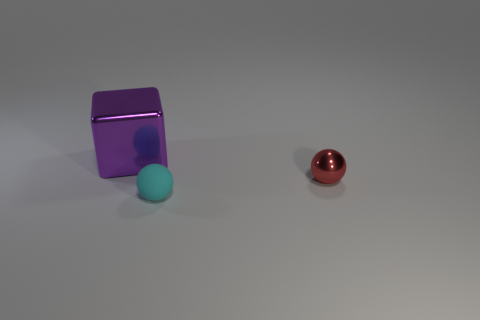Is the shape of the metallic thing that is to the left of the red metallic thing the same as the tiny thing that is right of the tiny rubber thing?
Give a very brief answer. No. Is there a tiny cyan ball?
Your response must be concise. Yes. There is a tiny red object that is the same shape as the cyan thing; what is it made of?
Offer a very short reply. Metal. There is a tiny cyan rubber ball; are there any small cyan objects behind it?
Provide a succinct answer. No. Does the small ball behind the tiny matte object have the same material as the big purple cube?
Keep it short and to the point. Yes. Are there any spheres of the same color as the big metallic object?
Your response must be concise. No. What shape is the big purple object?
Your answer should be compact. Cube. What color is the object behind the ball that is behind the rubber sphere?
Provide a short and direct response. Purple. There is a shiny thing that is right of the large cube; how big is it?
Your answer should be compact. Small. Are there any tiny cyan cylinders that have the same material as the big block?
Keep it short and to the point. No. 